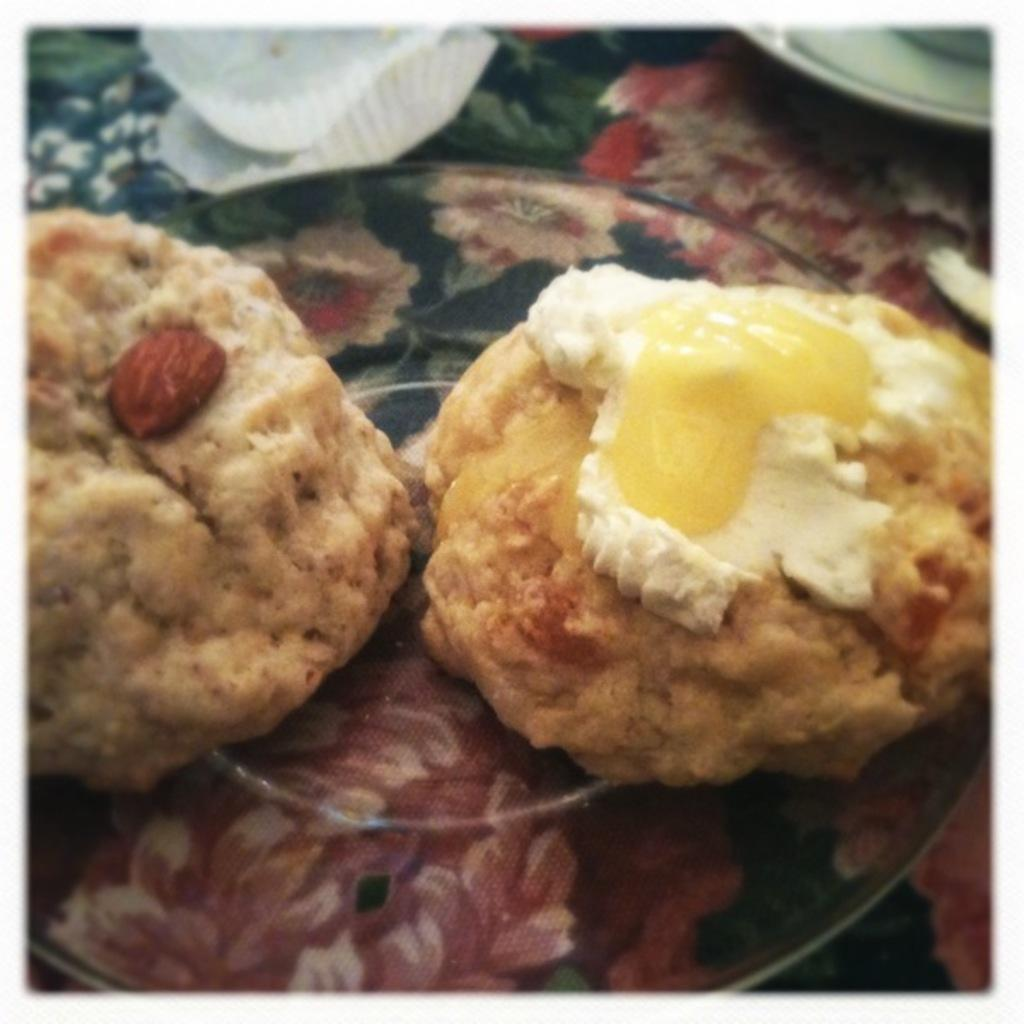What colors can be seen in the food in the image? The food in the image has cream, yellow, and white colors. How is the food arranged in the image? The food is on a plate. Can you describe the design of the plate? The plate has a multicolor design. What song is being played in the background of the image? There is no information about any song being played in the image. 